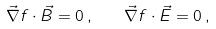Convert formula to latex. <formula><loc_0><loc_0><loc_500><loc_500>\vec { \nabla } f \cdot \vec { B } = 0 \, , \quad \vec { \nabla } f \cdot \vec { E } = 0 \, ,</formula> 